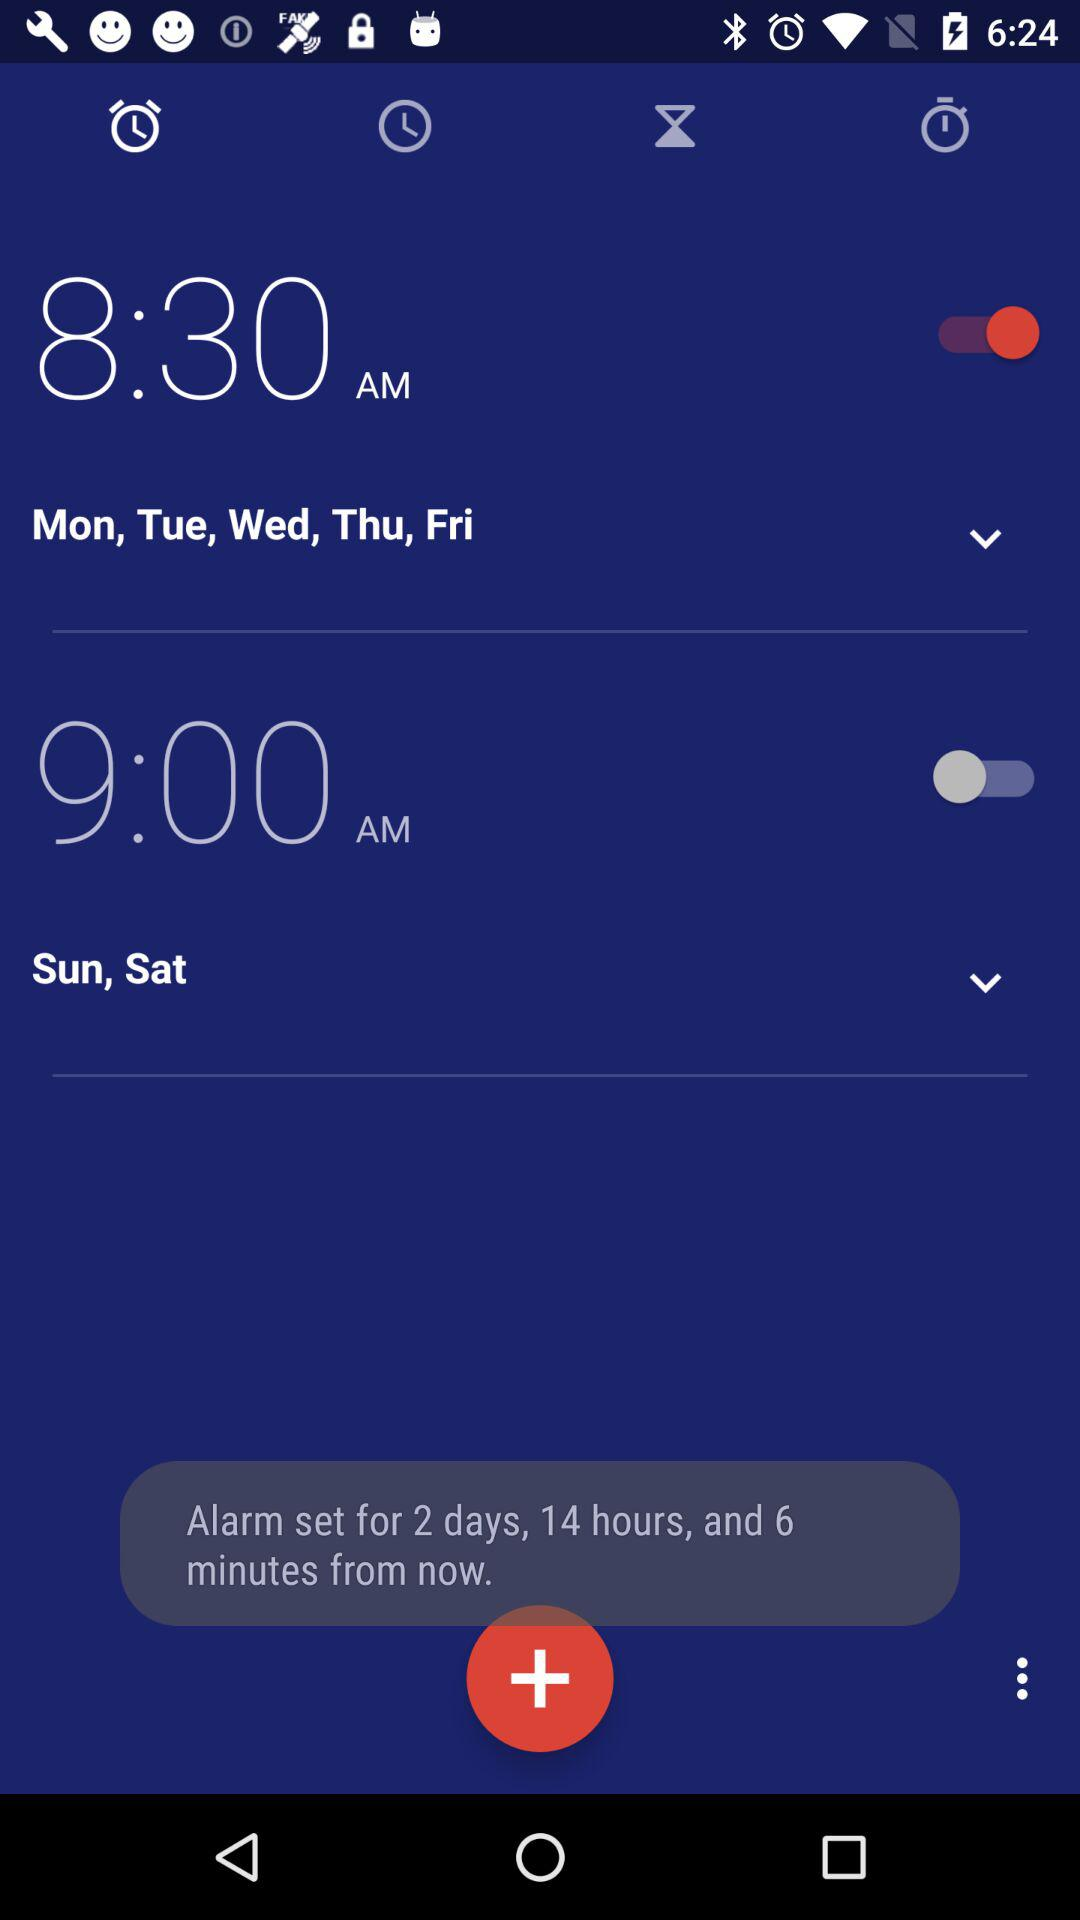How long will it take for the alarm to ring now? It will take 2 days, 14 hours, and 6 minutes for the alarm to ring now. 